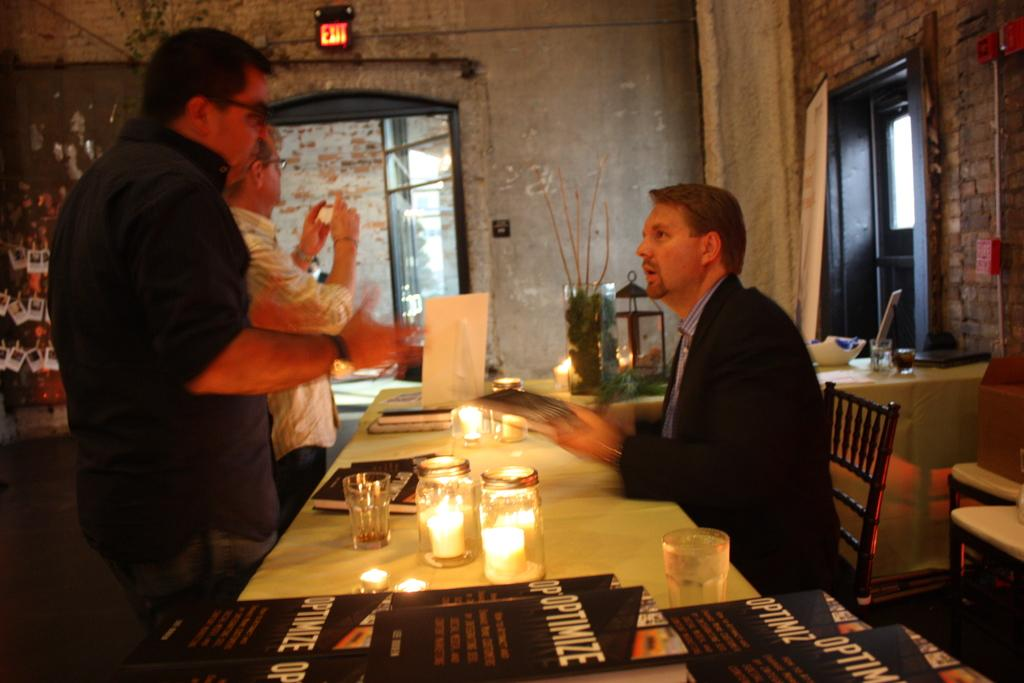What is the person near the table doing? The person is sitting on a chair near the table. What are the people standing near the table doing? There are people standing near the table, but their actions are not specified in the facts. What objects are on the table? There are jars, glasses, and cards on the table. What type of stew is being served in the image? There is no stew present in the image. What impulse might have caused the people to gather around the table? The facts do not provide any information about the reason for the people gathering around the table, so we cannot determine the impulse that caused them to do so. 